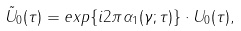<formula> <loc_0><loc_0><loc_500><loc_500>\tilde { U } _ { 0 } ( \tau ) = e x p \{ i 2 \pi \alpha _ { 1 } ( \gamma ; \tau ) \} \cdot U _ { 0 } ( \tau ) ,</formula> 